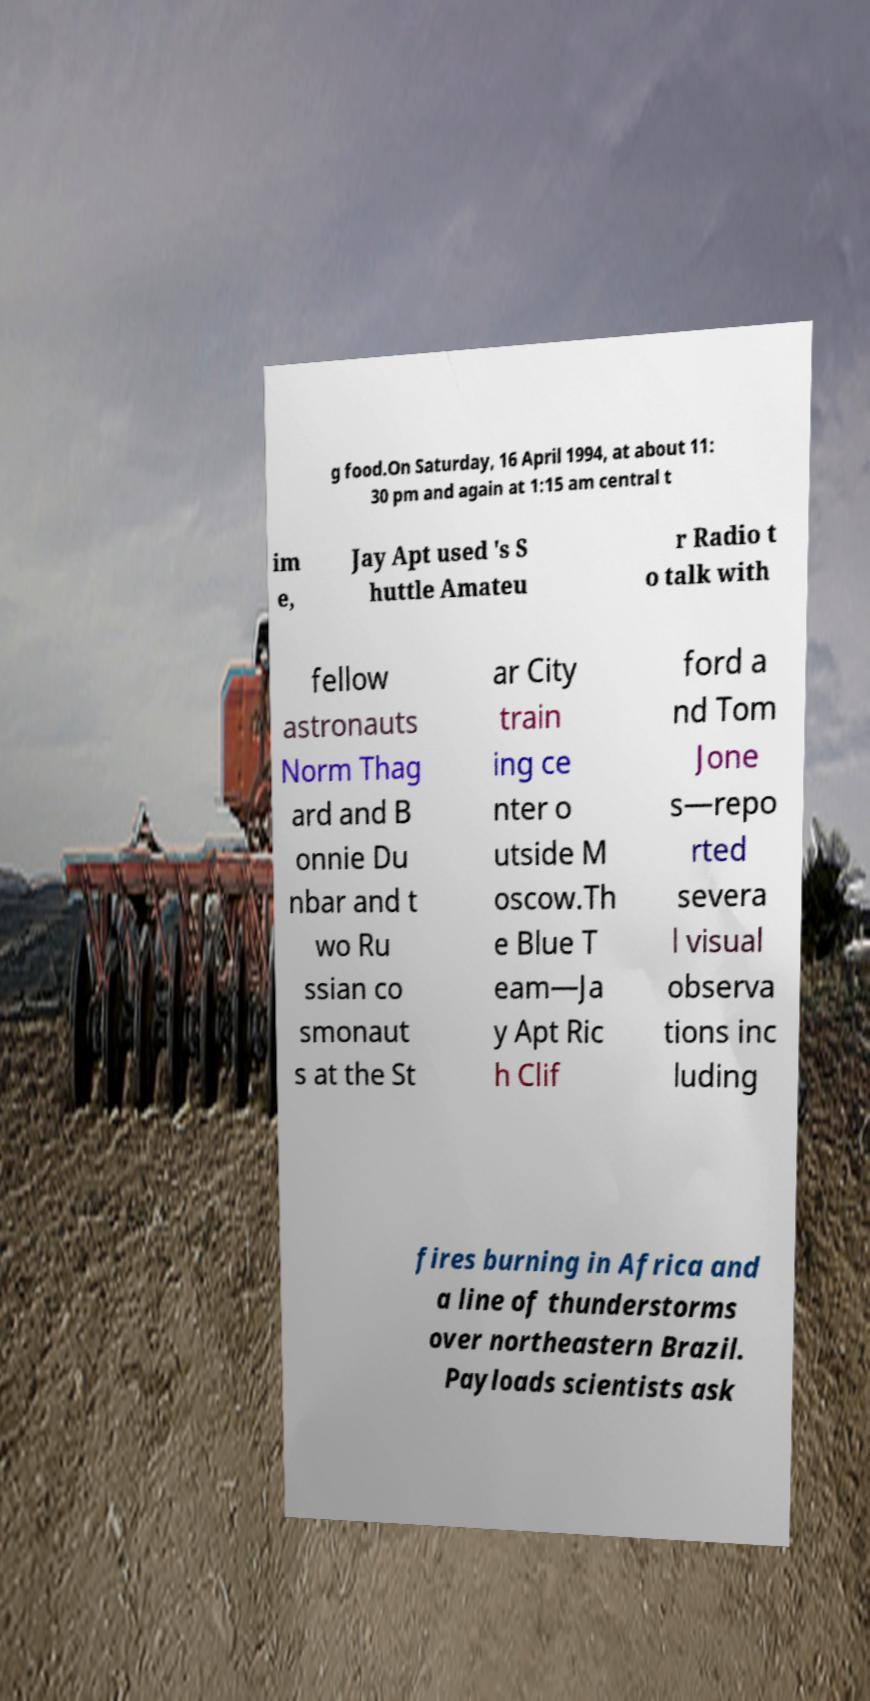Can you read and provide the text displayed in the image?This photo seems to have some interesting text. Can you extract and type it out for me? g food.On Saturday, 16 April 1994, at about 11: 30 pm and again at 1:15 am central t im e, Jay Apt used 's S huttle Amateu r Radio t o talk with fellow astronauts Norm Thag ard and B onnie Du nbar and t wo Ru ssian co smonaut s at the St ar City train ing ce nter o utside M oscow.Th e Blue T eam—Ja y Apt Ric h Clif ford a nd Tom Jone s—repo rted severa l visual observa tions inc luding fires burning in Africa and a line of thunderstorms over northeastern Brazil. Payloads scientists ask 